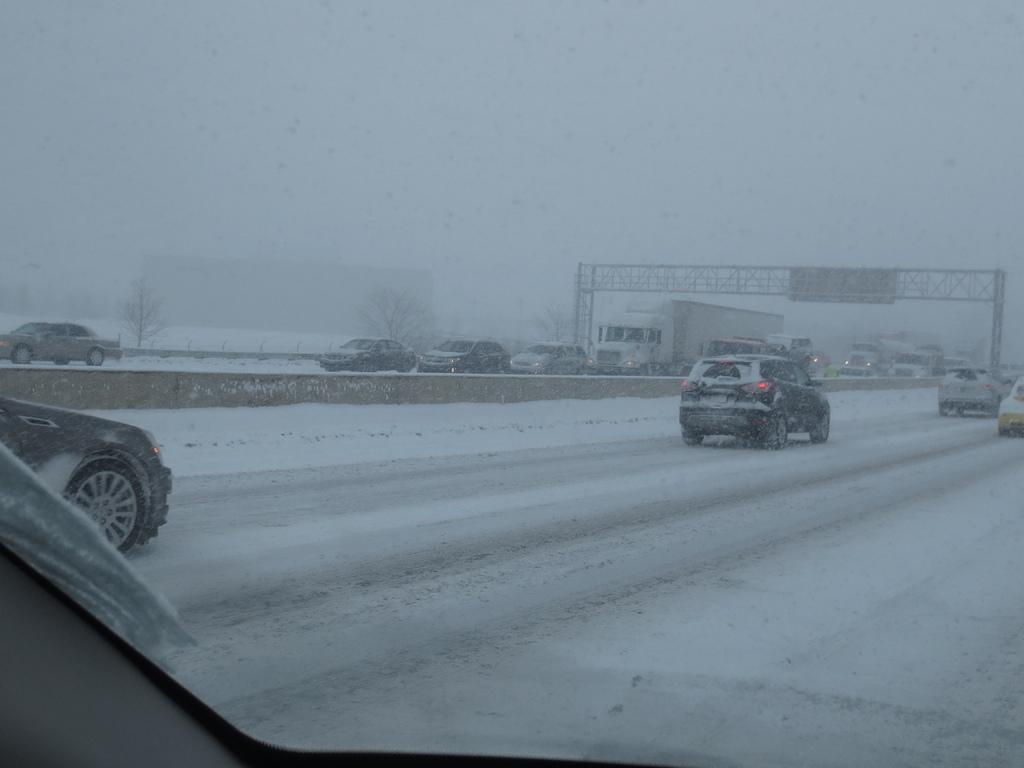What is happening on the road in the image? There are vehicles on the road in the image. What is the condition of the ground in the image? Snow is visible on the ground in the image. What type of structure can be seen in the image? There is a bridge in the image. What type of vegetation is present in the image? Trees are present in the image. What type of canvas is being used to paint the dock in the image? There is no canvas or dock present in the image. What type of paper is being used to draw the trees in the image? There is no paper or drawing of trees in the image; the trees are depicted as they are in real life. 